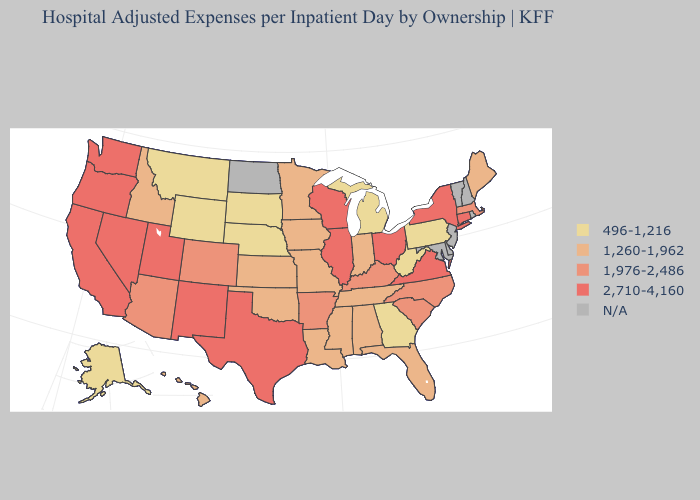What is the highest value in the USA?
Keep it brief. 2,710-4,160. Which states have the lowest value in the Northeast?
Write a very short answer. Pennsylvania. What is the highest value in the South ?
Short answer required. 2,710-4,160. Name the states that have a value in the range 2,710-4,160?
Be succinct. California, Connecticut, Illinois, Nevada, New Mexico, New York, Ohio, Oregon, Texas, Utah, Virginia, Washington, Wisconsin. What is the highest value in the USA?
Concise answer only. 2,710-4,160. Which states hav the highest value in the MidWest?
Concise answer only. Illinois, Ohio, Wisconsin. What is the value of Maine?
Write a very short answer. 1,260-1,962. How many symbols are there in the legend?
Short answer required. 5. How many symbols are there in the legend?
Answer briefly. 5. Name the states that have a value in the range 496-1,216?
Give a very brief answer. Alaska, Georgia, Michigan, Montana, Nebraska, Pennsylvania, South Dakota, West Virginia, Wyoming. What is the highest value in the MidWest ?
Short answer required. 2,710-4,160. Does Nebraska have the highest value in the USA?
Answer briefly. No. Does the first symbol in the legend represent the smallest category?
Be succinct. Yes. Name the states that have a value in the range 1,260-1,962?
Concise answer only. Alabama, Florida, Hawaii, Idaho, Indiana, Iowa, Kansas, Louisiana, Maine, Minnesota, Mississippi, Missouri, Oklahoma, Tennessee. 